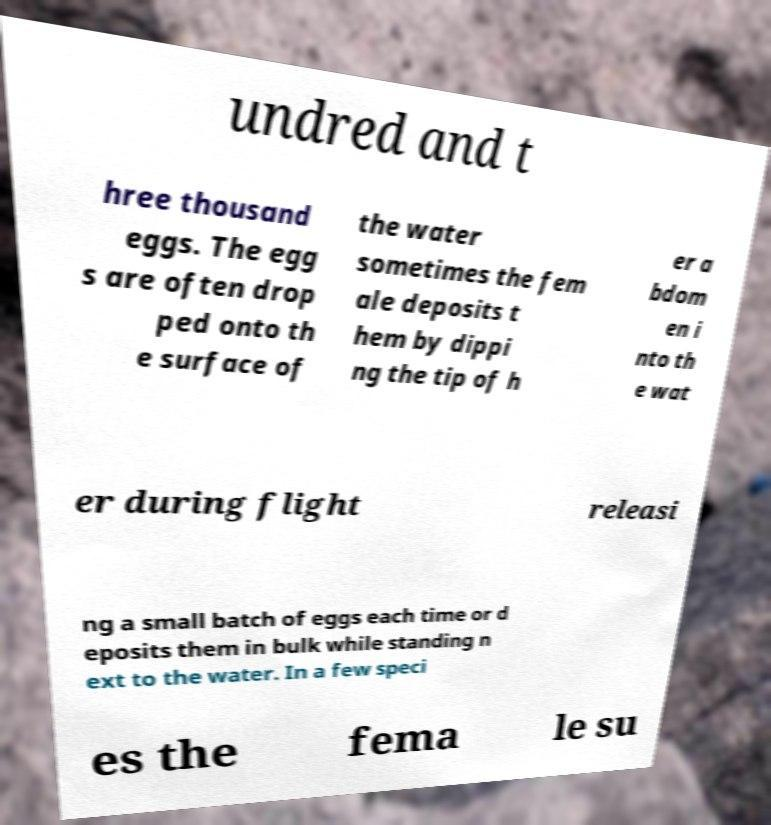Can you read and provide the text displayed in the image?This photo seems to have some interesting text. Can you extract and type it out for me? undred and t hree thousand eggs. The egg s are often drop ped onto th e surface of the water sometimes the fem ale deposits t hem by dippi ng the tip of h er a bdom en i nto th e wat er during flight releasi ng a small batch of eggs each time or d eposits them in bulk while standing n ext to the water. In a few speci es the fema le su 